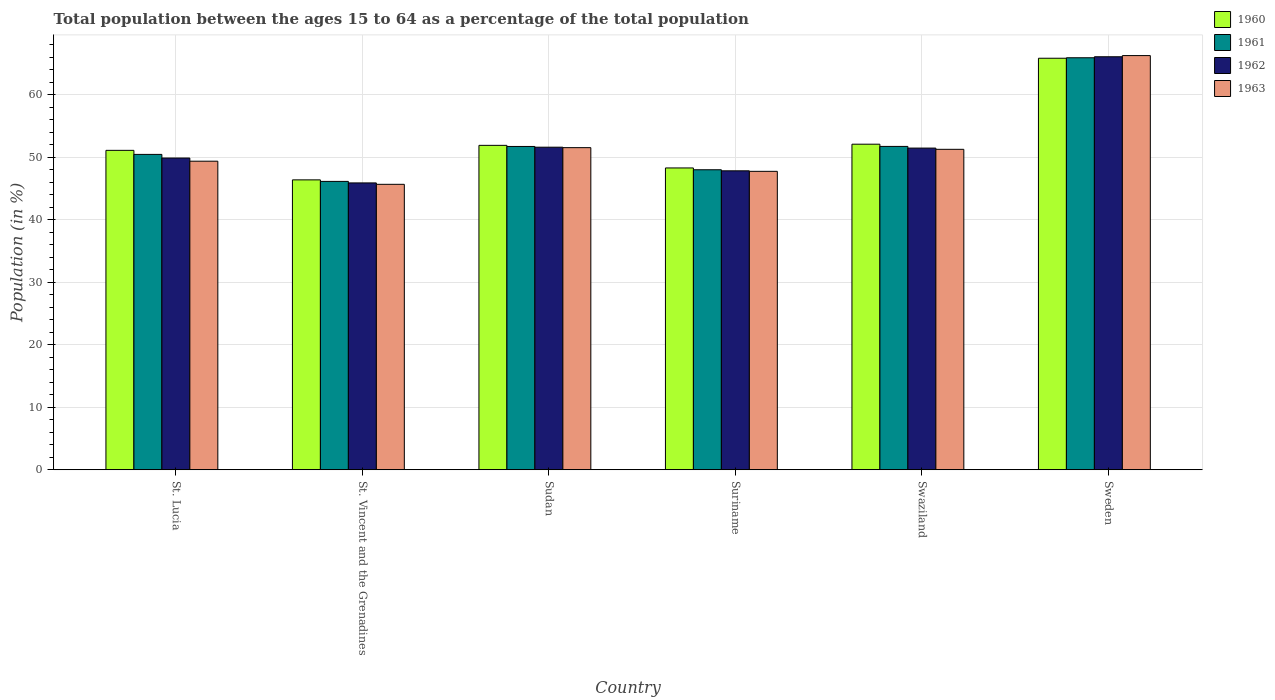How many different coloured bars are there?
Offer a terse response. 4. How many groups of bars are there?
Offer a very short reply. 6. Are the number of bars per tick equal to the number of legend labels?
Your answer should be compact. Yes. What is the label of the 3rd group of bars from the left?
Your answer should be very brief. Sudan. In how many cases, is the number of bars for a given country not equal to the number of legend labels?
Keep it short and to the point. 0. What is the percentage of the population ages 15 to 64 in 1963 in Sweden?
Offer a terse response. 66.24. Across all countries, what is the maximum percentage of the population ages 15 to 64 in 1962?
Ensure brevity in your answer.  66.06. Across all countries, what is the minimum percentage of the population ages 15 to 64 in 1960?
Make the answer very short. 46.37. In which country was the percentage of the population ages 15 to 64 in 1963 minimum?
Your answer should be very brief. St. Vincent and the Grenadines. What is the total percentage of the population ages 15 to 64 in 1960 in the graph?
Keep it short and to the point. 315.5. What is the difference between the percentage of the population ages 15 to 64 in 1960 in St. Vincent and the Grenadines and that in Swaziland?
Ensure brevity in your answer.  -5.7. What is the difference between the percentage of the population ages 15 to 64 in 1961 in Swaziland and the percentage of the population ages 15 to 64 in 1962 in Sweden?
Your answer should be compact. -14.34. What is the average percentage of the population ages 15 to 64 in 1961 per country?
Give a very brief answer. 52.31. What is the difference between the percentage of the population ages 15 to 64 of/in 1962 and percentage of the population ages 15 to 64 of/in 1961 in Swaziland?
Offer a terse response. -0.27. What is the ratio of the percentage of the population ages 15 to 64 in 1961 in St. Lucia to that in Swaziland?
Make the answer very short. 0.98. Is the percentage of the population ages 15 to 64 in 1961 in Suriname less than that in Swaziland?
Give a very brief answer. Yes. What is the difference between the highest and the second highest percentage of the population ages 15 to 64 in 1960?
Provide a succinct answer. 13.93. What is the difference between the highest and the lowest percentage of the population ages 15 to 64 in 1960?
Keep it short and to the point. 19.45. In how many countries, is the percentage of the population ages 15 to 64 in 1963 greater than the average percentage of the population ages 15 to 64 in 1963 taken over all countries?
Provide a short and direct response. 1. What does the 2nd bar from the left in St. Vincent and the Grenadines represents?
Keep it short and to the point. 1961. What does the 4th bar from the right in Sudan represents?
Your answer should be very brief. 1960. How many bars are there?
Provide a short and direct response. 24. Are all the bars in the graph horizontal?
Provide a short and direct response. No. How many countries are there in the graph?
Offer a terse response. 6. What is the difference between two consecutive major ticks on the Y-axis?
Keep it short and to the point. 10. Does the graph contain any zero values?
Provide a succinct answer. No. Where does the legend appear in the graph?
Offer a terse response. Top right. How many legend labels are there?
Ensure brevity in your answer.  4. What is the title of the graph?
Your answer should be compact. Total population between the ages 15 to 64 as a percentage of the total population. What is the label or title of the Y-axis?
Offer a terse response. Population (in %). What is the Population (in %) in 1960 in St. Lucia?
Your answer should be very brief. 51.09. What is the Population (in %) in 1961 in St. Lucia?
Ensure brevity in your answer.  50.44. What is the Population (in %) of 1962 in St. Lucia?
Provide a short and direct response. 49.86. What is the Population (in %) of 1963 in St. Lucia?
Keep it short and to the point. 49.35. What is the Population (in %) of 1960 in St. Vincent and the Grenadines?
Ensure brevity in your answer.  46.37. What is the Population (in %) in 1961 in St. Vincent and the Grenadines?
Provide a short and direct response. 46.12. What is the Population (in %) of 1962 in St. Vincent and the Grenadines?
Ensure brevity in your answer.  45.88. What is the Population (in %) of 1963 in St. Vincent and the Grenadines?
Provide a succinct answer. 45.66. What is the Population (in %) in 1960 in Sudan?
Keep it short and to the point. 51.89. What is the Population (in %) in 1961 in Sudan?
Ensure brevity in your answer.  51.71. What is the Population (in %) of 1962 in Sudan?
Offer a very short reply. 51.59. What is the Population (in %) in 1963 in Sudan?
Your answer should be compact. 51.52. What is the Population (in %) in 1960 in Suriname?
Provide a succinct answer. 48.27. What is the Population (in %) in 1961 in Suriname?
Your answer should be compact. 47.98. What is the Population (in %) of 1962 in Suriname?
Your answer should be compact. 47.81. What is the Population (in %) of 1963 in Suriname?
Keep it short and to the point. 47.73. What is the Population (in %) in 1960 in Swaziland?
Provide a short and direct response. 52.07. What is the Population (in %) of 1961 in Swaziland?
Ensure brevity in your answer.  51.72. What is the Population (in %) in 1962 in Swaziland?
Provide a short and direct response. 51.45. What is the Population (in %) of 1963 in Swaziland?
Your answer should be compact. 51.25. What is the Population (in %) of 1960 in Sweden?
Give a very brief answer. 65.82. What is the Population (in %) in 1961 in Sweden?
Offer a very short reply. 65.89. What is the Population (in %) of 1962 in Sweden?
Provide a short and direct response. 66.06. What is the Population (in %) in 1963 in Sweden?
Make the answer very short. 66.24. Across all countries, what is the maximum Population (in %) in 1960?
Your answer should be compact. 65.82. Across all countries, what is the maximum Population (in %) of 1961?
Provide a short and direct response. 65.89. Across all countries, what is the maximum Population (in %) of 1962?
Provide a short and direct response. 66.06. Across all countries, what is the maximum Population (in %) of 1963?
Provide a short and direct response. 66.24. Across all countries, what is the minimum Population (in %) in 1960?
Give a very brief answer. 46.37. Across all countries, what is the minimum Population (in %) in 1961?
Give a very brief answer. 46.12. Across all countries, what is the minimum Population (in %) in 1962?
Give a very brief answer. 45.88. Across all countries, what is the minimum Population (in %) of 1963?
Your answer should be very brief. 45.66. What is the total Population (in %) of 1960 in the graph?
Ensure brevity in your answer.  315.5. What is the total Population (in %) in 1961 in the graph?
Ensure brevity in your answer.  313.87. What is the total Population (in %) in 1962 in the graph?
Offer a very short reply. 312.65. What is the total Population (in %) of 1963 in the graph?
Make the answer very short. 311.75. What is the difference between the Population (in %) of 1960 in St. Lucia and that in St. Vincent and the Grenadines?
Provide a succinct answer. 4.72. What is the difference between the Population (in %) in 1961 in St. Lucia and that in St. Vincent and the Grenadines?
Provide a succinct answer. 4.32. What is the difference between the Population (in %) of 1962 in St. Lucia and that in St. Vincent and the Grenadines?
Your answer should be compact. 3.98. What is the difference between the Population (in %) of 1963 in St. Lucia and that in St. Vincent and the Grenadines?
Provide a short and direct response. 3.7. What is the difference between the Population (in %) of 1960 in St. Lucia and that in Sudan?
Offer a very short reply. -0.8. What is the difference between the Population (in %) in 1961 in St. Lucia and that in Sudan?
Offer a very short reply. -1.27. What is the difference between the Population (in %) of 1962 in St. Lucia and that in Sudan?
Offer a terse response. -1.73. What is the difference between the Population (in %) in 1963 in St. Lucia and that in Sudan?
Your answer should be very brief. -2.17. What is the difference between the Population (in %) of 1960 in St. Lucia and that in Suriname?
Your answer should be compact. 2.81. What is the difference between the Population (in %) in 1961 in St. Lucia and that in Suriname?
Keep it short and to the point. 2.46. What is the difference between the Population (in %) in 1962 in St. Lucia and that in Suriname?
Offer a very short reply. 2.05. What is the difference between the Population (in %) in 1963 in St. Lucia and that in Suriname?
Your answer should be compact. 1.62. What is the difference between the Population (in %) in 1960 in St. Lucia and that in Swaziland?
Provide a succinct answer. -0.99. What is the difference between the Population (in %) of 1961 in St. Lucia and that in Swaziland?
Provide a succinct answer. -1.28. What is the difference between the Population (in %) of 1962 in St. Lucia and that in Swaziland?
Offer a very short reply. -1.59. What is the difference between the Population (in %) of 1963 in St. Lucia and that in Swaziland?
Ensure brevity in your answer.  -1.9. What is the difference between the Population (in %) of 1960 in St. Lucia and that in Sweden?
Give a very brief answer. -14.73. What is the difference between the Population (in %) of 1961 in St. Lucia and that in Sweden?
Offer a terse response. -15.45. What is the difference between the Population (in %) in 1962 in St. Lucia and that in Sweden?
Your answer should be compact. -16.2. What is the difference between the Population (in %) of 1963 in St. Lucia and that in Sweden?
Provide a succinct answer. -16.89. What is the difference between the Population (in %) of 1960 in St. Vincent and the Grenadines and that in Sudan?
Offer a terse response. -5.52. What is the difference between the Population (in %) of 1961 in St. Vincent and the Grenadines and that in Sudan?
Give a very brief answer. -5.59. What is the difference between the Population (in %) of 1962 in St. Vincent and the Grenadines and that in Sudan?
Offer a very short reply. -5.71. What is the difference between the Population (in %) in 1963 in St. Vincent and the Grenadines and that in Sudan?
Provide a short and direct response. -5.86. What is the difference between the Population (in %) in 1960 in St. Vincent and the Grenadines and that in Suriname?
Give a very brief answer. -1.9. What is the difference between the Population (in %) of 1961 in St. Vincent and the Grenadines and that in Suriname?
Provide a succinct answer. -1.86. What is the difference between the Population (in %) in 1962 in St. Vincent and the Grenadines and that in Suriname?
Provide a succinct answer. -1.93. What is the difference between the Population (in %) of 1963 in St. Vincent and the Grenadines and that in Suriname?
Keep it short and to the point. -2.08. What is the difference between the Population (in %) of 1960 in St. Vincent and the Grenadines and that in Swaziland?
Give a very brief answer. -5.7. What is the difference between the Population (in %) of 1961 in St. Vincent and the Grenadines and that in Swaziland?
Your answer should be very brief. -5.59. What is the difference between the Population (in %) of 1962 in St. Vincent and the Grenadines and that in Swaziland?
Provide a succinct answer. -5.57. What is the difference between the Population (in %) in 1963 in St. Vincent and the Grenadines and that in Swaziland?
Offer a very short reply. -5.6. What is the difference between the Population (in %) in 1960 in St. Vincent and the Grenadines and that in Sweden?
Your answer should be very brief. -19.45. What is the difference between the Population (in %) in 1961 in St. Vincent and the Grenadines and that in Sweden?
Your answer should be compact. -19.77. What is the difference between the Population (in %) in 1962 in St. Vincent and the Grenadines and that in Sweden?
Offer a terse response. -20.18. What is the difference between the Population (in %) in 1963 in St. Vincent and the Grenadines and that in Sweden?
Keep it short and to the point. -20.59. What is the difference between the Population (in %) of 1960 in Sudan and that in Suriname?
Ensure brevity in your answer.  3.61. What is the difference between the Population (in %) of 1961 in Sudan and that in Suriname?
Give a very brief answer. 3.73. What is the difference between the Population (in %) of 1962 in Sudan and that in Suriname?
Your answer should be compact. 3.78. What is the difference between the Population (in %) in 1963 in Sudan and that in Suriname?
Make the answer very short. 3.79. What is the difference between the Population (in %) in 1960 in Sudan and that in Swaziland?
Provide a succinct answer. -0.19. What is the difference between the Population (in %) in 1961 in Sudan and that in Swaziland?
Your answer should be very brief. -0.01. What is the difference between the Population (in %) in 1962 in Sudan and that in Swaziland?
Your answer should be compact. 0.14. What is the difference between the Population (in %) in 1963 in Sudan and that in Swaziland?
Provide a succinct answer. 0.27. What is the difference between the Population (in %) in 1960 in Sudan and that in Sweden?
Keep it short and to the point. -13.93. What is the difference between the Population (in %) in 1961 in Sudan and that in Sweden?
Offer a terse response. -14.18. What is the difference between the Population (in %) of 1962 in Sudan and that in Sweden?
Your answer should be compact. -14.46. What is the difference between the Population (in %) in 1963 in Sudan and that in Sweden?
Provide a short and direct response. -14.72. What is the difference between the Population (in %) in 1960 in Suriname and that in Swaziland?
Your response must be concise. -3.8. What is the difference between the Population (in %) of 1961 in Suriname and that in Swaziland?
Provide a short and direct response. -3.73. What is the difference between the Population (in %) of 1962 in Suriname and that in Swaziland?
Give a very brief answer. -3.64. What is the difference between the Population (in %) in 1963 in Suriname and that in Swaziland?
Your answer should be very brief. -3.52. What is the difference between the Population (in %) in 1960 in Suriname and that in Sweden?
Offer a terse response. -17.54. What is the difference between the Population (in %) of 1961 in Suriname and that in Sweden?
Your response must be concise. -17.91. What is the difference between the Population (in %) of 1962 in Suriname and that in Sweden?
Ensure brevity in your answer.  -18.24. What is the difference between the Population (in %) in 1963 in Suriname and that in Sweden?
Give a very brief answer. -18.51. What is the difference between the Population (in %) of 1960 in Swaziland and that in Sweden?
Give a very brief answer. -13.74. What is the difference between the Population (in %) of 1961 in Swaziland and that in Sweden?
Your answer should be very brief. -14.18. What is the difference between the Population (in %) of 1962 in Swaziland and that in Sweden?
Your response must be concise. -14.61. What is the difference between the Population (in %) in 1963 in Swaziland and that in Sweden?
Keep it short and to the point. -14.99. What is the difference between the Population (in %) of 1960 in St. Lucia and the Population (in %) of 1961 in St. Vincent and the Grenadines?
Make the answer very short. 4.96. What is the difference between the Population (in %) in 1960 in St. Lucia and the Population (in %) in 1962 in St. Vincent and the Grenadines?
Your response must be concise. 5.21. What is the difference between the Population (in %) of 1960 in St. Lucia and the Population (in %) of 1963 in St. Vincent and the Grenadines?
Provide a short and direct response. 5.43. What is the difference between the Population (in %) of 1961 in St. Lucia and the Population (in %) of 1962 in St. Vincent and the Grenadines?
Your answer should be compact. 4.56. What is the difference between the Population (in %) of 1961 in St. Lucia and the Population (in %) of 1963 in St. Vincent and the Grenadines?
Your answer should be very brief. 4.78. What is the difference between the Population (in %) of 1962 in St. Lucia and the Population (in %) of 1963 in St. Vincent and the Grenadines?
Ensure brevity in your answer.  4.2. What is the difference between the Population (in %) of 1960 in St. Lucia and the Population (in %) of 1961 in Sudan?
Offer a terse response. -0.62. What is the difference between the Population (in %) of 1960 in St. Lucia and the Population (in %) of 1962 in Sudan?
Offer a terse response. -0.51. What is the difference between the Population (in %) of 1960 in St. Lucia and the Population (in %) of 1963 in Sudan?
Give a very brief answer. -0.43. What is the difference between the Population (in %) of 1961 in St. Lucia and the Population (in %) of 1962 in Sudan?
Keep it short and to the point. -1.15. What is the difference between the Population (in %) in 1961 in St. Lucia and the Population (in %) in 1963 in Sudan?
Offer a terse response. -1.08. What is the difference between the Population (in %) in 1962 in St. Lucia and the Population (in %) in 1963 in Sudan?
Your answer should be very brief. -1.66. What is the difference between the Population (in %) in 1960 in St. Lucia and the Population (in %) in 1961 in Suriname?
Make the answer very short. 3.1. What is the difference between the Population (in %) in 1960 in St. Lucia and the Population (in %) in 1962 in Suriname?
Your answer should be very brief. 3.27. What is the difference between the Population (in %) in 1960 in St. Lucia and the Population (in %) in 1963 in Suriname?
Offer a very short reply. 3.35. What is the difference between the Population (in %) in 1961 in St. Lucia and the Population (in %) in 1962 in Suriname?
Your response must be concise. 2.63. What is the difference between the Population (in %) of 1961 in St. Lucia and the Population (in %) of 1963 in Suriname?
Your answer should be very brief. 2.71. What is the difference between the Population (in %) of 1962 in St. Lucia and the Population (in %) of 1963 in Suriname?
Your response must be concise. 2.13. What is the difference between the Population (in %) in 1960 in St. Lucia and the Population (in %) in 1961 in Swaziland?
Ensure brevity in your answer.  -0.63. What is the difference between the Population (in %) in 1960 in St. Lucia and the Population (in %) in 1962 in Swaziland?
Provide a succinct answer. -0.36. What is the difference between the Population (in %) of 1960 in St. Lucia and the Population (in %) of 1963 in Swaziland?
Provide a succinct answer. -0.17. What is the difference between the Population (in %) of 1961 in St. Lucia and the Population (in %) of 1962 in Swaziland?
Provide a short and direct response. -1.01. What is the difference between the Population (in %) of 1961 in St. Lucia and the Population (in %) of 1963 in Swaziland?
Provide a succinct answer. -0.81. What is the difference between the Population (in %) of 1962 in St. Lucia and the Population (in %) of 1963 in Swaziland?
Make the answer very short. -1.39. What is the difference between the Population (in %) of 1960 in St. Lucia and the Population (in %) of 1961 in Sweden?
Give a very brief answer. -14.81. What is the difference between the Population (in %) in 1960 in St. Lucia and the Population (in %) in 1962 in Sweden?
Keep it short and to the point. -14.97. What is the difference between the Population (in %) in 1960 in St. Lucia and the Population (in %) in 1963 in Sweden?
Provide a short and direct response. -15.16. What is the difference between the Population (in %) in 1961 in St. Lucia and the Population (in %) in 1962 in Sweden?
Offer a very short reply. -15.62. What is the difference between the Population (in %) in 1961 in St. Lucia and the Population (in %) in 1963 in Sweden?
Give a very brief answer. -15.8. What is the difference between the Population (in %) in 1962 in St. Lucia and the Population (in %) in 1963 in Sweden?
Give a very brief answer. -16.38. What is the difference between the Population (in %) in 1960 in St. Vincent and the Grenadines and the Population (in %) in 1961 in Sudan?
Your answer should be very brief. -5.34. What is the difference between the Population (in %) in 1960 in St. Vincent and the Grenadines and the Population (in %) in 1962 in Sudan?
Your answer should be very brief. -5.22. What is the difference between the Population (in %) of 1960 in St. Vincent and the Grenadines and the Population (in %) of 1963 in Sudan?
Keep it short and to the point. -5.15. What is the difference between the Population (in %) in 1961 in St. Vincent and the Grenadines and the Population (in %) in 1962 in Sudan?
Keep it short and to the point. -5.47. What is the difference between the Population (in %) in 1961 in St. Vincent and the Grenadines and the Population (in %) in 1963 in Sudan?
Ensure brevity in your answer.  -5.4. What is the difference between the Population (in %) in 1962 in St. Vincent and the Grenadines and the Population (in %) in 1963 in Sudan?
Give a very brief answer. -5.64. What is the difference between the Population (in %) in 1960 in St. Vincent and the Grenadines and the Population (in %) in 1961 in Suriname?
Ensure brevity in your answer.  -1.62. What is the difference between the Population (in %) in 1960 in St. Vincent and the Grenadines and the Population (in %) in 1962 in Suriname?
Provide a short and direct response. -1.44. What is the difference between the Population (in %) in 1960 in St. Vincent and the Grenadines and the Population (in %) in 1963 in Suriname?
Your answer should be compact. -1.36. What is the difference between the Population (in %) in 1961 in St. Vincent and the Grenadines and the Population (in %) in 1962 in Suriname?
Provide a short and direct response. -1.69. What is the difference between the Population (in %) of 1961 in St. Vincent and the Grenadines and the Population (in %) of 1963 in Suriname?
Your answer should be compact. -1.61. What is the difference between the Population (in %) in 1962 in St. Vincent and the Grenadines and the Population (in %) in 1963 in Suriname?
Your response must be concise. -1.85. What is the difference between the Population (in %) of 1960 in St. Vincent and the Grenadines and the Population (in %) of 1961 in Swaziland?
Your answer should be very brief. -5.35. What is the difference between the Population (in %) in 1960 in St. Vincent and the Grenadines and the Population (in %) in 1962 in Swaziland?
Ensure brevity in your answer.  -5.08. What is the difference between the Population (in %) of 1960 in St. Vincent and the Grenadines and the Population (in %) of 1963 in Swaziland?
Provide a succinct answer. -4.88. What is the difference between the Population (in %) in 1961 in St. Vincent and the Grenadines and the Population (in %) in 1962 in Swaziland?
Ensure brevity in your answer.  -5.33. What is the difference between the Population (in %) in 1961 in St. Vincent and the Grenadines and the Population (in %) in 1963 in Swaziland?
Keep it short and to the point. -5.13. What is the difference between the Population (in %) of 1962 in St. Vincent and the Grenadines and the Population (in %) of 1963 in Swaziland?
Your answer should be very brief. -5.37. What is the difference between the Population (in %) of 1960 in St. Vincent and the Grenadines and the Population (in %) of 1961 in Sweden?
Keep it short and to the point. -19.53. What is the difference between the Population (in %) in 1960 in St. Vincent and the Grenadines and the Population (in %) in 1962 in Sweden?
Offer a very short reply. -19.69. What is the difference between the Population (in %) in 1960 in St. Vincent and the Grenadines and the Population (in %) in 1963 in Sweden?
Make the answer very short. -19.87. What is the difference between the Population (in %) in 1961 in St. Vincent and the Grenadines and the Population (in %) in 1962 in Sweden?
Your response must be concise. -19.93. What is the difference between the Population (in %) of 1961 in St. Vincent and the Grenadines and the Population (in %) of 1963 in Sweden?
Provide a succinct answer. -20.12. What is the difference between the Population (in %) of 1962 in St. Vincent and the Grenadines and the Population (in %) of 1963 in Sweden?
Provide a succinct answer. -20.36. What is the difference between the Population (in %) in 1960 in Sudan and the Population (in %) in 1961 in Suriname?
Provide a succinct answer. 3.9. What is the difference between the Population (in %) of 1960 in Sudan and the Population (in %) of 1962 in Suriname?
Provide a succinct answer. 4.07. What is the difference between the Population (in %) in 1960 in Sudan and the Population (in %) in 1963 in Suriname?
Ensure brevity in your answer.  4.16. What is the difference between the Population (in %) in 1961 in Sudan and the Population (in %) in 1962 in Suriname?
Provide a succinct answer. 3.9. What is the difference between the Population (in %) in 1961 in Sudan and the Population (in %) in 1963 in Suriname?
Keep it short and to the point. 3.98. What is the difference between the Population (in %) of 1962 in Sudan and the Population (in %) of 1963 in Suriname?
Provide a succinct answer. 3.86. What is the difference between the Population (in %) of 1960 in Sudan and the Population (in %) of 1961 in Swaziland?
Your answer should be very brief. 0.17. What is the difference between the Population (in %) in 1960 in Sudan and the Population (in %) in 1962 in Swaziland?
Your response must be concise. 0.44. What is the difference between the Population (in %) in 1960 in Sudan and the Population (in %) in 1963 in Swaziland?
Offer a very short reply. 0.64. What is the difference between the Population (in %) of 1961 in Sudan and the Population (in %) of 1962 in Swaziland?
Provide a short and direct response. 0.26. What is the difference between the Population (in %) of 1961 in Sudan and the Population (in %) of 1963 in Swaziland?
Provide a succinct answer. 0.46. What is the difference between the Population (in %) in 1962 in Sudan and the Population (in %) in 1963 in Swaziland?
Provide a short and direct response. 0.34. What is the difference between the Population (in %) of 1960 in Sudan and the Population (in %) of 1961 in Sweden?
Make the answer very short. -14.01. What is the difference between the Population (in %) of 1960 in Sudan and the Population (in %) of 1962 in Sweden?
Provide a succinct answer. -14.17. What is the difference between the Population (in %) in 1960 in Sudan and the Population (in %) in 1963 in Sweden?
Offer a terse response. -14.36. What is the difference between the Population (in %) in 1961 in Sudan and the Population (in %) in 1962 in Sweden?
Provide a succinct answer. -14.35. What is the difference between the Population (in %) in 1961 in Sudan and the Population (in %) in 1963 in Sweden?
Your answer should be very brief. -14.53. What is the difference between the Population (in %) in 1962 in Sudan and the Population (in %) in 1963 in Sweden?
Offer a very short reply. -14.65. What is the difference between the Population (in %) in 1960 in Suriname and the Population (in %) in 1961 in Swaziland?
Offer a terse response. -3.44. What is the difference between the Population (in %) in 1960 in Suriname and the Population (in %) in 1962 in Swaziland?
Your answer should be very brief. -3.18. What is the difference between the Population (in %) of 1960 in Suriname and the Population (in %) of 1963 in Swaziland?
Provide a succinct answer. -2.98. What is the difference between the Population (in %) in 1961 in Suriname and the Population (in %) in 1962 in Swaziland?
Make the answer very short. -3.47. What is the difference between the Population (in %) in 1961 in Suriname and the Population (in %) in 1963 in Swaziland?
Your answer should be compact. -3.27. What is the difference between the Population (in %) in 1962 in Suriname and the Population (in %) in 1963 in Swaziland?
Your answer should be very brief. -3.44. What is the difference between the Population (in %) of 1960 in Suriname and the Population (in %) of 1961 in Sweden?
Offer a terse response. -17.62. What is the difference between the Population (in %) in 1960 in Suriname and the Population (in %) in 1962 in Sweden?
Make the answer very short. -17.78. What is the difference between the Population (in %) in 1960 in Suriname and the Population (in %) in 1963 in Sweden?
Provide a short and direct response. -17.97. What is the difference between the Population (in %) of 1961 in Suriname and the Population (in %) of 1962 in Sweden?
Provide a short and direct response. -18.07. What is the difference between the Population (in %) in 1961 in Suriname and the Population (in %) in 1963 in Sweden?
Your response must be concise. -18.26. What is the difference between the Population (in %) in 1962 in Suriname and the Population (in %) in 1963 in Sweden?
Make the answer very short. -18.43. What is the difference between the Population (in %) in 1960 in Swaziland and the Population (in %) in 1961 in Sweden?
Give a very brief answer. -13.82. What is the difference between the Population (in %) in 1960 in Swaziland and the Population (in %) in 1962 in Sweden?
Give a very brief answer. -13.98. What is the difference between the Population (in %) in 1960 in Swaziland and the Population (in %) in 1963 in Sweden?
Offer a terse response. -14.17. What is the difference between the Population (in %) in 1961 in Swaziland and the Population (in %) in 1962 in Sweden?
Offer a very short reply. -14.34. What is the difference between the Population (in %) of 1961 in Swaziland and the Population (in %) of 1963 in Sweden?
Your answer should be compact. -14.53. What is the difference between the Population (in %) of 1962 in Swaziland and the Population (in %) of 1963 in Sweden?
Ensure brevity in your answer.  -14.79. What is the average Population (in %) in 1960 per country?
Provide a succinct answer. 52.58. What is the average Population (in %) of 1961 per country?
Your answer should be very brief. 52.31. What is the average Population (in %) of 1962 per country?
Offer a very short reply. 52.11. What is the average Population (in %) in 1963 per country?
Make the answer very short. 51.96. What is the difference between the Population (in %) in 1960 and Population (in %) in 1961 in St. Lucia?
Give a very brief answer. 0.65. What is the difference between the Population (in %) in 1960 and Population (in %) in 1962 in St. Lucia?
Your answer should be very brief. 1.23. What is the difference between the Population (in %) of 1960 and Population (in %) of 1963 in St. Lucia?
Ensure brevity in your answer.  1.73. What is the difference between the Population (in %) of 1961 and Population (in %) of 1962 in St. Lucia?
Your answer should be compact. 0.58. What is the difference between the Population (in %) of 1961 and Population (in %) of 1963 in St. Lucia?
Your answer should be very brief. 1.09. What is the difference between the Population (in %) of 1962 and Population (in %) of 1963 in St. Lucia?
Offer a terse response. 0.51. What is the difference between the Population (in %) of 1960 and Population (in %) of 1961 in St. Vincent and the Grenadines?
Your response must be concise. 0.25. What is the difference between the Population (in %) of 1960 and Population (in %) of 1962 in St. Vincent and the Grenadines?
Provide a succinct answer. 0.49. What is the difference between the Population (in %) in 1960 and Population (in %) in 1963 in St. Vincent and the Grenadines?
Provide a short and direct response. 0.71. What is the difference between the Population (in %) in 1961 and Population (in %) in 1962 in St. Vincent and the Grenadines?
Give a very brief answer. 0.24. What is the difference between the Population (in %) in 1961 and Population (in %) in 1963 in St. Vincent and the Grenadines?
Offer a terse response. 0.47. What is the difference between the Population (in %) of 1962 and Population (in %) of 1963 in St. Vincent and the Grenadines?
Give a very brief answer. 0.22. What is the difference between the Population (in %) in 1960 and Population (in %) in 1961 in Sudan?
Your answer should be compact. 0.18. What is the difference between the Population (in %) of 1960 and Population (in %) of 1962 in Sudan?
Provide a short and direct response. 0.3. What is the difference between the Population (in %) of 1960 and Population (in %) of 1963 in Sudan?
Provide a short and direct response. 0.37. What is the difference between the Population (in %) in 1961 and Population (in %) in 1962 in Sudan?
Your response must be concise. 0.12. What is the difference between the Population (in %) of 1961 and Population (in %) of 1963 in Sudan?
Your answer should be compact. 0.19. What is the difference between the Population (in %) in 1962 and Population (in %) in 1963 in Sudan?
Provide a short and direct response. 0.07. What is the difference between the Population (in %) in 1960 and Population (in %) in 1961 in Suriname?
Provide a succinct answer. 0.29. What is the difference between the Population (in %) of 1960 and Population (in %) of 1962 in Suriname?
Keep it short and to the point. 0.46. What is the difference between the Population (in %) of 1960 and Population (in %) of 1963 in Suriname?
Offer a very short reply. 0.54. What is the difference between the Population (in %) of 1961 and Population (in %) of 1962 in Suriname?
Give a very brief answer. 0.17. What is the difference between the Population (in %) in 1961 and Population (in %) in 1963 in Suriname?
Make the answer very short. 0.25. What is the difference between the Population (in %) in 1962 and Population (in %) in 1963 in Suriname?
Your answer should be very brief. 0.08. What is the difference between the Population (in %) of 1960 and Population (in %) of 1961 in Swaziland?
Provide a succinct answer. 0.36. What is the difference between the Population (in %) in 1960 and Population (in %) in 1962 in Swaziland?
Keep it short and to the point. 0.62. What is the difference between the Population (in %) in 1960 and Population (in %) in 1963 in Swaziland?
Your answer should be very brief. 0.82. What is the difference between the Population (in %) of 1961 and Population (in %) of 1962 in Swaziland?
Make the answer very short. 0.27. What is the difference between the Population (in %) of 1961 and Population (in %) of 1963 in Swaziland?
Make the answer very short. 0.47. What is the difference between the Population (in %) of 1962 and Population (in %) of 1963 in Swaziland?
Provide a short and direct response. 0.2. What is the difference between the Population (in %) of 1960 and Population (in %) of 1961 in Sweden?
Make the answer very short. -0.08. What is the difference between the Population (in %) in 1960 and Population (in %) in 1962 in Sweden?
Give a very brief answer. -0.24. What is the difference between the Population (in %) in 1960 and Population (in %) in 1963 in Sweden?
Provide a short and direct response. -0.43. What is the difference between the Population (in %) of 1961 and Population (in %) of 1962 in Sweden?
Your response must be concise. -0.16. What is the difference between the Population (in %) in 1961 and Population (in %) in 1963 in Sweden?
Provide a succinct answer. -0.35. What is the difference between the Population (in %) in 1962 and Population (in %) in 1963 in Sweden?
Offer a very short reply. -0.19. What is the ratio of the Population (in %) in 1960 in St. Lucia to that in St. Vincent and the Grenadines?
Offer a terse response. 1.1. What is the ratio of the Population (in %) in 1961 in St. Lucia to that in St. Vincent and the Grenadines?
Keep it short and to the point. 1.09. What is the ratio of the Population (in %) of 1962 in St. Lucia to that in St. Vincent and the Grenadines?
Offer a very short reply. 1.09. What is the ratio of the Population (in %) in 1963 in St. Lucia to that in St. Vincent and the Grenadines?
Make the answer very short. 1.08. What is the ratio of the Population (in %) of 1960 in St. Lucia to that in Sudan?
Offer a terse response. 0.98. What is the ratio of the Population (in %) in 1961 in St. Lucia to that in Sudan?
Offer a terse response. 0.98. What is the ratio of the Population (in %) in 1962 in St. Lucia to that in Sudan?
Offer a very short reply. 0.97. What is the ratio of the Population (in %) of 1963 in St. Lucia to that in Sudan?
Offer a terse response. 0.96. What is the ratio of the Population (in %) of 1960 in St. Lucia to that in Suriname?
Your answer should be compact. 1.06. What is the ratio of the Population (in %) of 1961 in St. Lucia to that in Suriname?
Ensure brevity in your answer.  1.05. What is the ratio of the Population (in %) in 1962 in St. Lucia to that in Suriname?
Give a very brief answer. 1.04. What is the ratio of the Population (in %) of 1963 in St. Lucia to that in Suriname?
Give a very brief answer. 1.03. What is the ratio of the Population (in %) of 1960 in St. Lucia to that in Swaziland?
Provide a succinct answer. 0.98. What is the ratio of the Population (in %) of 1961 in St. Lucia to that in Swaziland?
Your response must be concise. 0.98. What is the ratio of the Population (in %) in 1962 in St. Lucia to that in Swaziland?
Your response must be concise. 0.97. What is the ratio of the Population (in %) of 1963 in St. Lucia to that in Swaziland?
Offer a very short reply. 0.96. What is the ratio of the Population (in %) of 1960 in St. Lucia to that in Sweden?
Ensure brevity in your answer.  0.78. What is the ratio of the Population (in %) of 1961 in St. Lucia to that in Sweden?
Give a very brief answer. 0.77. What is the ratio of the Population (in %) in 1962 in St. Lucia to that in Sweden?
Keep it short and to the point. 0.75. What is the ratio of the Population (in %) of 1963 in St. Lucia to that in Sweden?
Offer a terse response. 0.74. What is the ratio of the Population (in %) in 1960 in St. Vincent and the Grenadines to that in Sudan?
Ensure brevity in your answer.  0.89. What is the ratio of the Population (in %) of 1961 in St. Vincent and the Grenadines to that in Sudan?
Provide a short and direct response. 0.89. What is the ratio of the Population (in %) of 1962 in St. Vincent and the Grenadines to that in Sudan?
Your answer should be compact. 0.89. What is the ratio of the Population (in %) in 1963 in St. Vincent and the Grenadines to that in Sudan?
Give a very brief answer. 0.89. What is the ratio of the Population (in %) of 1960 in St. Vincent and the Grenadines to that in Suriname?
Provide a succinct answer. 0.96. What is the ratio of the Population (in %) of 1961 in St. Vincent and the Grenadines to that in Suriname?
Offer a terse response. 0.96. What is the ratio of the Population (in %) in 1962 in St. Vincent and the Grenadines to that in Suriname?
Give a very brief answer. 0.96. What is the ratio of the Population (in %) in 1963 in St. Vincent and the Grenadines to that in Suriname?
Give a very brief answer. 0.96. What is the ratio of the Population (in %) in 1960 in St. Vincent and the Grenadines to that in Swaziland?
Provide a short and direct response. 0.89. What is the ratio of the Population (in %) in 1961 in St. Vincent and the Grenadines to that in Swaziland?
Keep it short and to the point. 0.89. What is the ratio of the Population (in %) of 1962 in St. Vincent and the Grenadines to that in Swaziland?
Ensure brevity in your answer.  0.89. What is the ratio of the Population (in %) of 1963 in St. Vincent and the Grenadines to that in Swaziland?
Give a very brief answer. 0.89. What is the ratio of the Population (in %) in 1960 in St. Vincent and the Grenadines to that in Sweden?
Provide a short and direct response. 0.7. What is the ratio of the Population (in %) in 1962 in St. Vincent and the Grenadines to that in Sweden?
Ensure brevity in your answer.  0.69. What is the ratio of the Population (in %) of 1963 in St. Vincent and the Grenadines to that in Sweden?
Offer a terse response. 0.69. What is the ratio of the Population (in %) in 1960 in Sudan to that in Suriname?
Give a very brief answer. 1.07. What is the ratio of the Population (in %) in 1961 in Sudan to that in Suriname?
Offer a very short reply. 1.08. What is the ratio of the Population (in %) in 1962 in Sudan to that in Suriname?
Give a very brief answer. 1.08. What is the ratio of the Population (in %) in 1963 in Sudan to that in Suriname?
Give a very brief answer. 1.08. What is the ratio of the Population (in %) in 1963 in Sudan to that in Swaziland?
Offer a very short reply. 1.01. What is the ratio of the Population (in %) of 1960 in Sudan to that in Sweden?
Provide a succinct answer. 0.79. What is the ratio of the Population (in %) in 1961 in Sudan to that in Sweden?
Provide a succinct answer. 0.78. What is the ratio of the Population (in %) of 1962 in Sudan to that in Sweden?
Provide a short and direct response. 0.78. What is the ratio of the Population (in %) of 1963 in Sudan to that in Sweden?
Your response must be concise. 0.78. What is the ratio of the Population (in %) in 1960 in Suriname to that in Swaziland?
Offer a terse response. 0.93. What is the ratio of the Population (in %) in 1961 in Suriname to that in Swaziland?
Your response must be concise. 0.93. What is the ratio of the Population (in %) in 1962 in Suriname to that in Swaziland?
Offer a terse response. 0.93. What is the ratio of the Population (in %) in 1963 in Suriname to that in Swaziland?
Your response must be concise. 0.93. What is the ratio of the Population (in %) in 1960 in Suriname to that in Sweden?
Offer a very short reply. 0.73. What is the ratio of the Population (in %) in 1961 in Suriname to that in Sweden?
Keep it short and to the point. 0.73. What is the ratio of the Population (in %) of 1962 in Suriname to that in Sweden?
Keep it short and to the point. 0.72. What is the ratio of the Population (in %) in 1963 in Suriname to that in Sweden?
Offer a very short reply. 0.72. What is the ratio of the Population (in %) of 1960 in Swaziland to that in Sweden?
Provide a short and direct response. 0.79. What is the ratio of the Population (in %) in 1961 in Swaziland to that in Sweden?
Make the answer very short. 0.78. What is the ratio of the Population (in %) of 1962 in Swaziland to that in Sweden?
Keep it short and to the point. 0.78. What is the ratio of the Population (in %) of 1963 in Swaziland to that in Sweden?
Your response must be concise. 0.77. What is the difference between the highest and the second highest Population (in %) of 1960?
Offer a very short reply. 13.74. What is the difference between the highest and the second highest Population (in %) in 1961?
Your response must be concise. 14.18. What is the difference between the highest and the second highest Population (in %) in 1962?
Keep it short and to the point. 14.46. What is the difference between the highest and the second highest Population (in %) in 1963?
Your answer should be compact. 14.72. What is the difference between the highest and the lowest Population (in %) in 1960?
Provide a short and direct response. 19.45. What is the difference between the highest and the lowest Population (in %) of 1961?
Ensure brevity in your answer.  19.77. What is the difference between the highest and the lowest Population (in %) of 1962?
Give a very brief answer. 20.18. What is the difference between the highest and the lowest Population (in %) in 1963?
Your answer should be very brief. 20.59. 